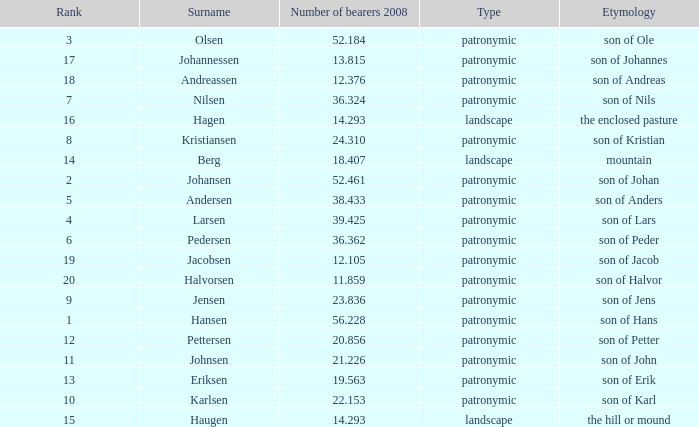Could you parse the entire table as a dict? {'header': ['Rank', 'Surname', 'Number of bearers 2008', 'Type', 'Etymology'], 'rows': [['3', 'Olsen', '52.184', 'patronymic', 'son of Ole'], ['17', 'Johannessen', '13.815', 'patronymic', 'son of Johannes'], ['18', 'Andreassen', '12.376', 'patronymic', 'son of Andreas'], ['7', 'Nilsen', '36.324', 'patronymic', 'son of Nils'], ['16', 'Hagen', '14.293', 'landscape', 'the enclosed pasture'], ['8', 'Kristiansen', '24.310', 'patronymic', 'son of Kristian'], ['14', 'Berg', '18.407', 'landscape', 'mountain'], ['2', 'Johansen', '52.461', 'patronymic', 'son of Johan'], ['5', 'Andersen', '38.433', 'patronymic', 'son of Anders'], ['4', 'Larsen', '39.425', 'patronymic', 'son of Lars'], ['6', 'Pedersen', '36.362', 'patronymic', 'son of Peder'], ['19', 'Jacobsen', '12.105', 'patronymic', 'son of Jacob'], ['20', 'Halvorsen', '11.859', 'patronymic', 'son of Halvor'], ['9', 'Jensen', '23.836', 'patronymic', 'son of Jens'], ['1', 'Hansen', '56.228', 'patronymic', 'son of Hans'], ['12', 'Pettersen', '20.856', 'patronymic', 'son of Petter'], ['11', 'Johnsen', '21.226', 'patronymic', 'son of John'], ['13', 'Eriksen', '19.563', 'patronymic', 'son of Erik'], ['10', 'Karlsen', '22.153', 'patronymic', 'son of Karl'], ['15', 'Haugen', '14.293', 'landscape', 'the hill or mound']]} What is Type, when Number of Bearers 2008 is greater than 12.376, when Rank is greater than 3, and when Etymology is Son of Jens? Patronymic. 